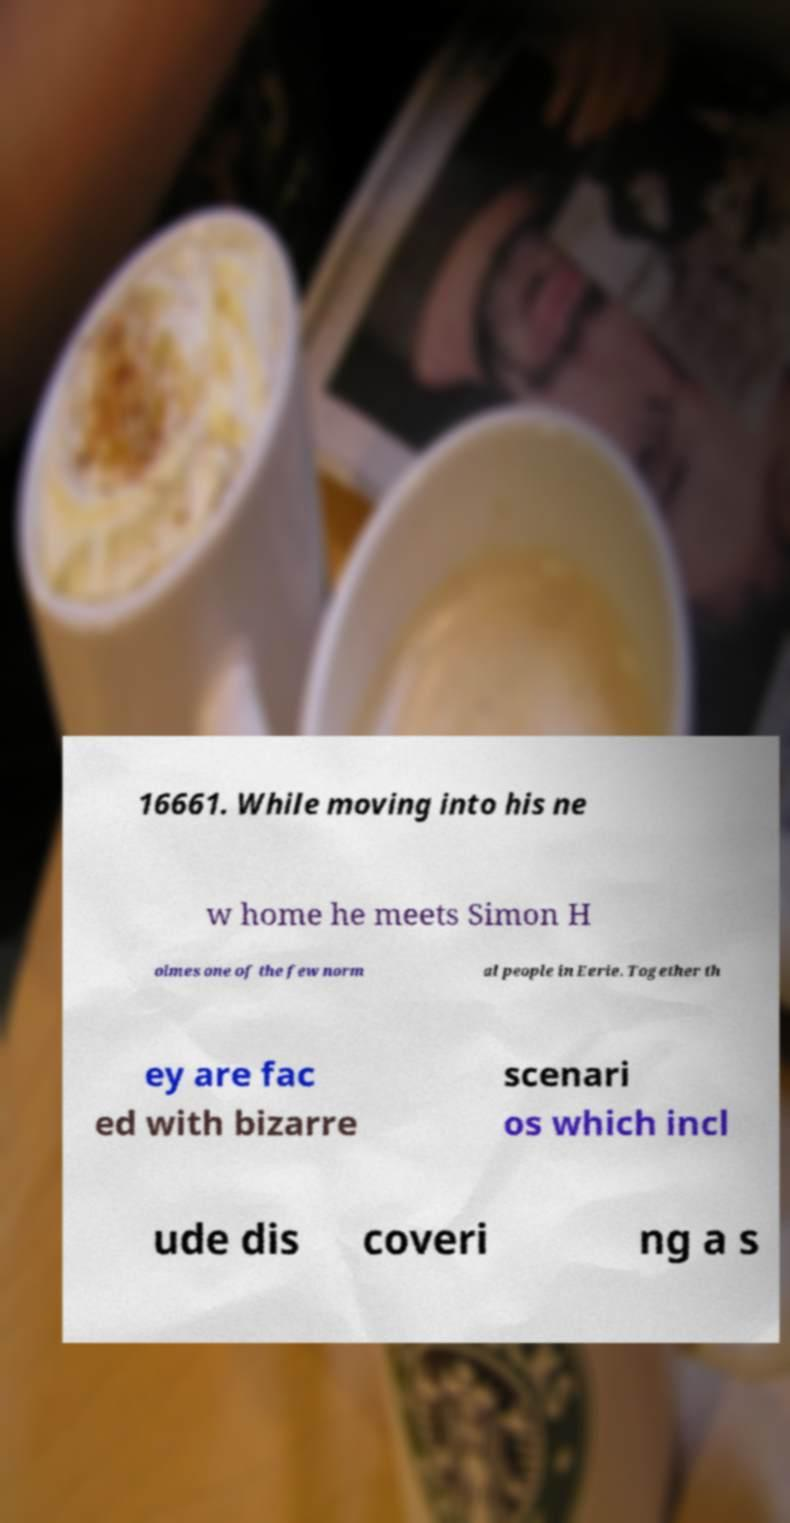I need the written content from this picture converted into text. Can you do that? 16661. While moving into his ne w home he meets Simon H olmes one of the few norm al people in Eerie. Together th ey are fac ed with bizarre scenari os which incl ude dis coveri ng a s 